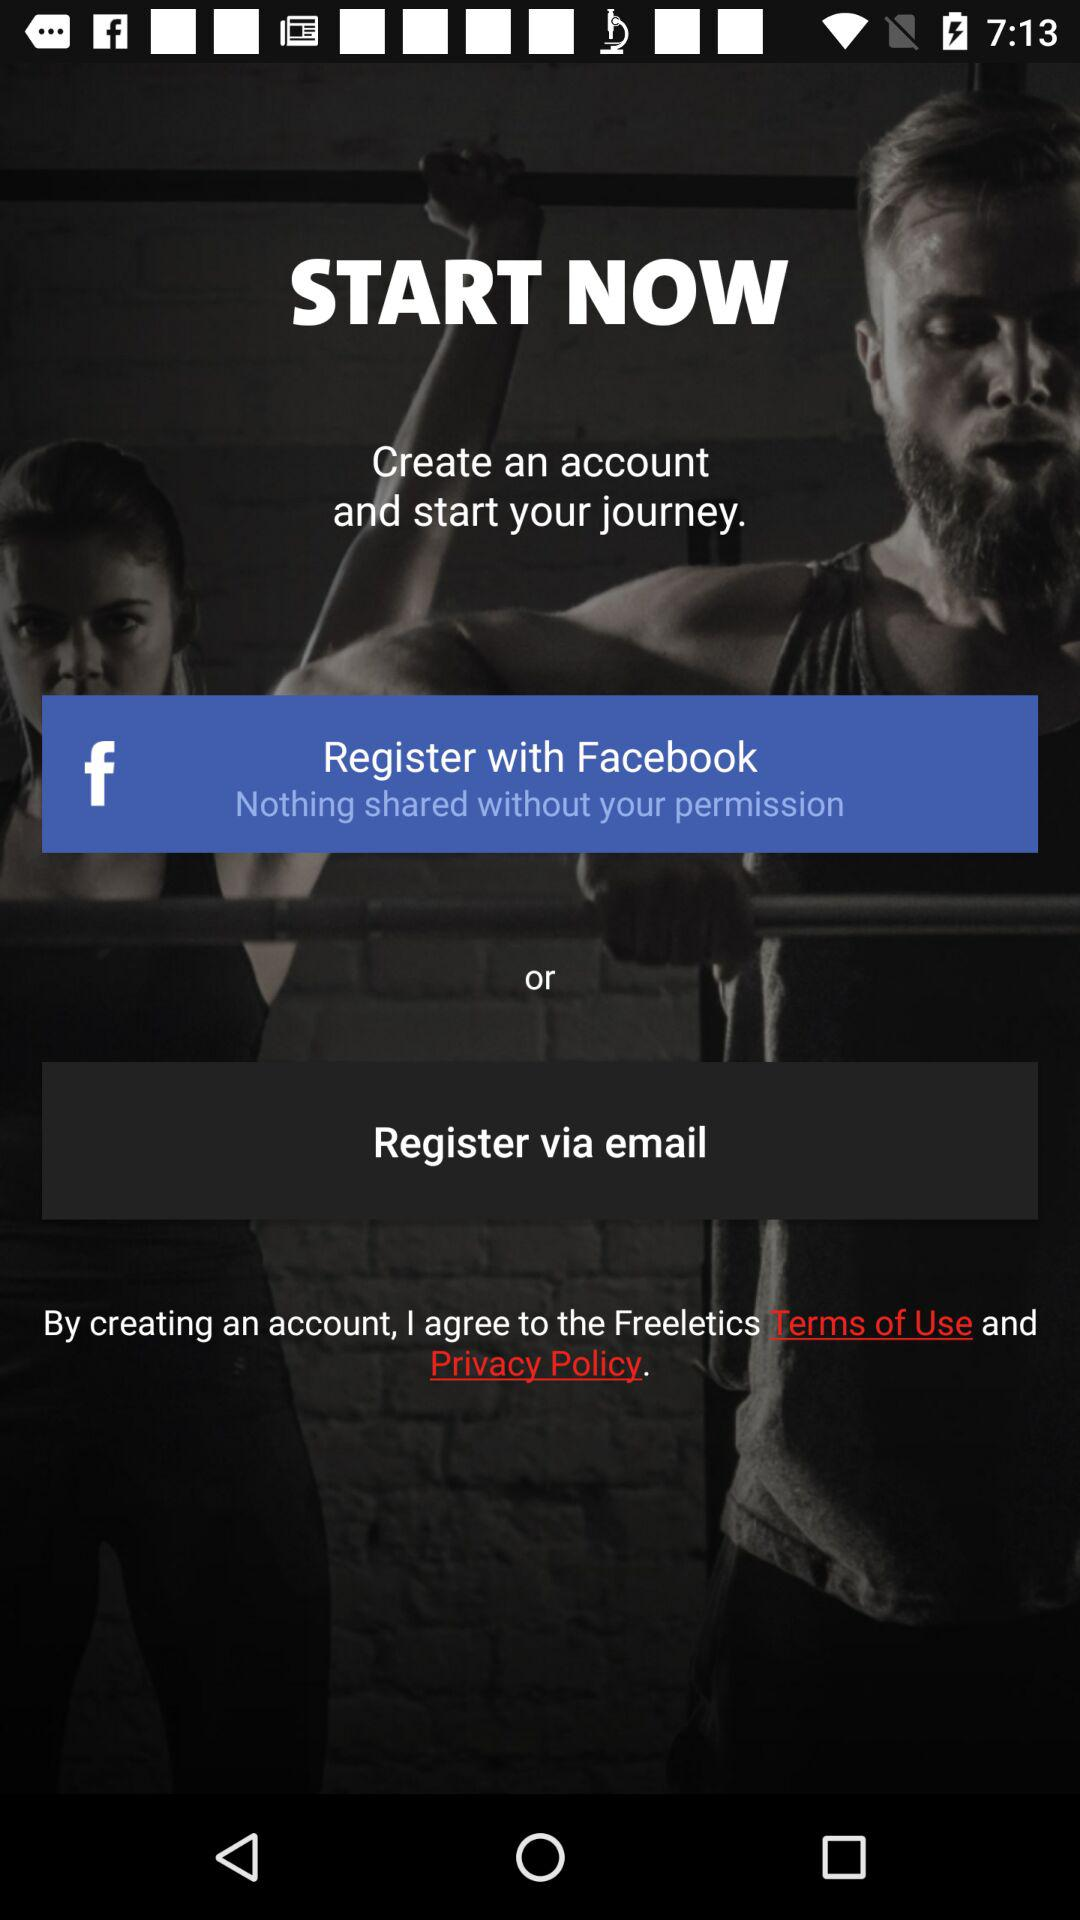What account can I use to register? The accounts you can use to register are "Facebook" and "email". 